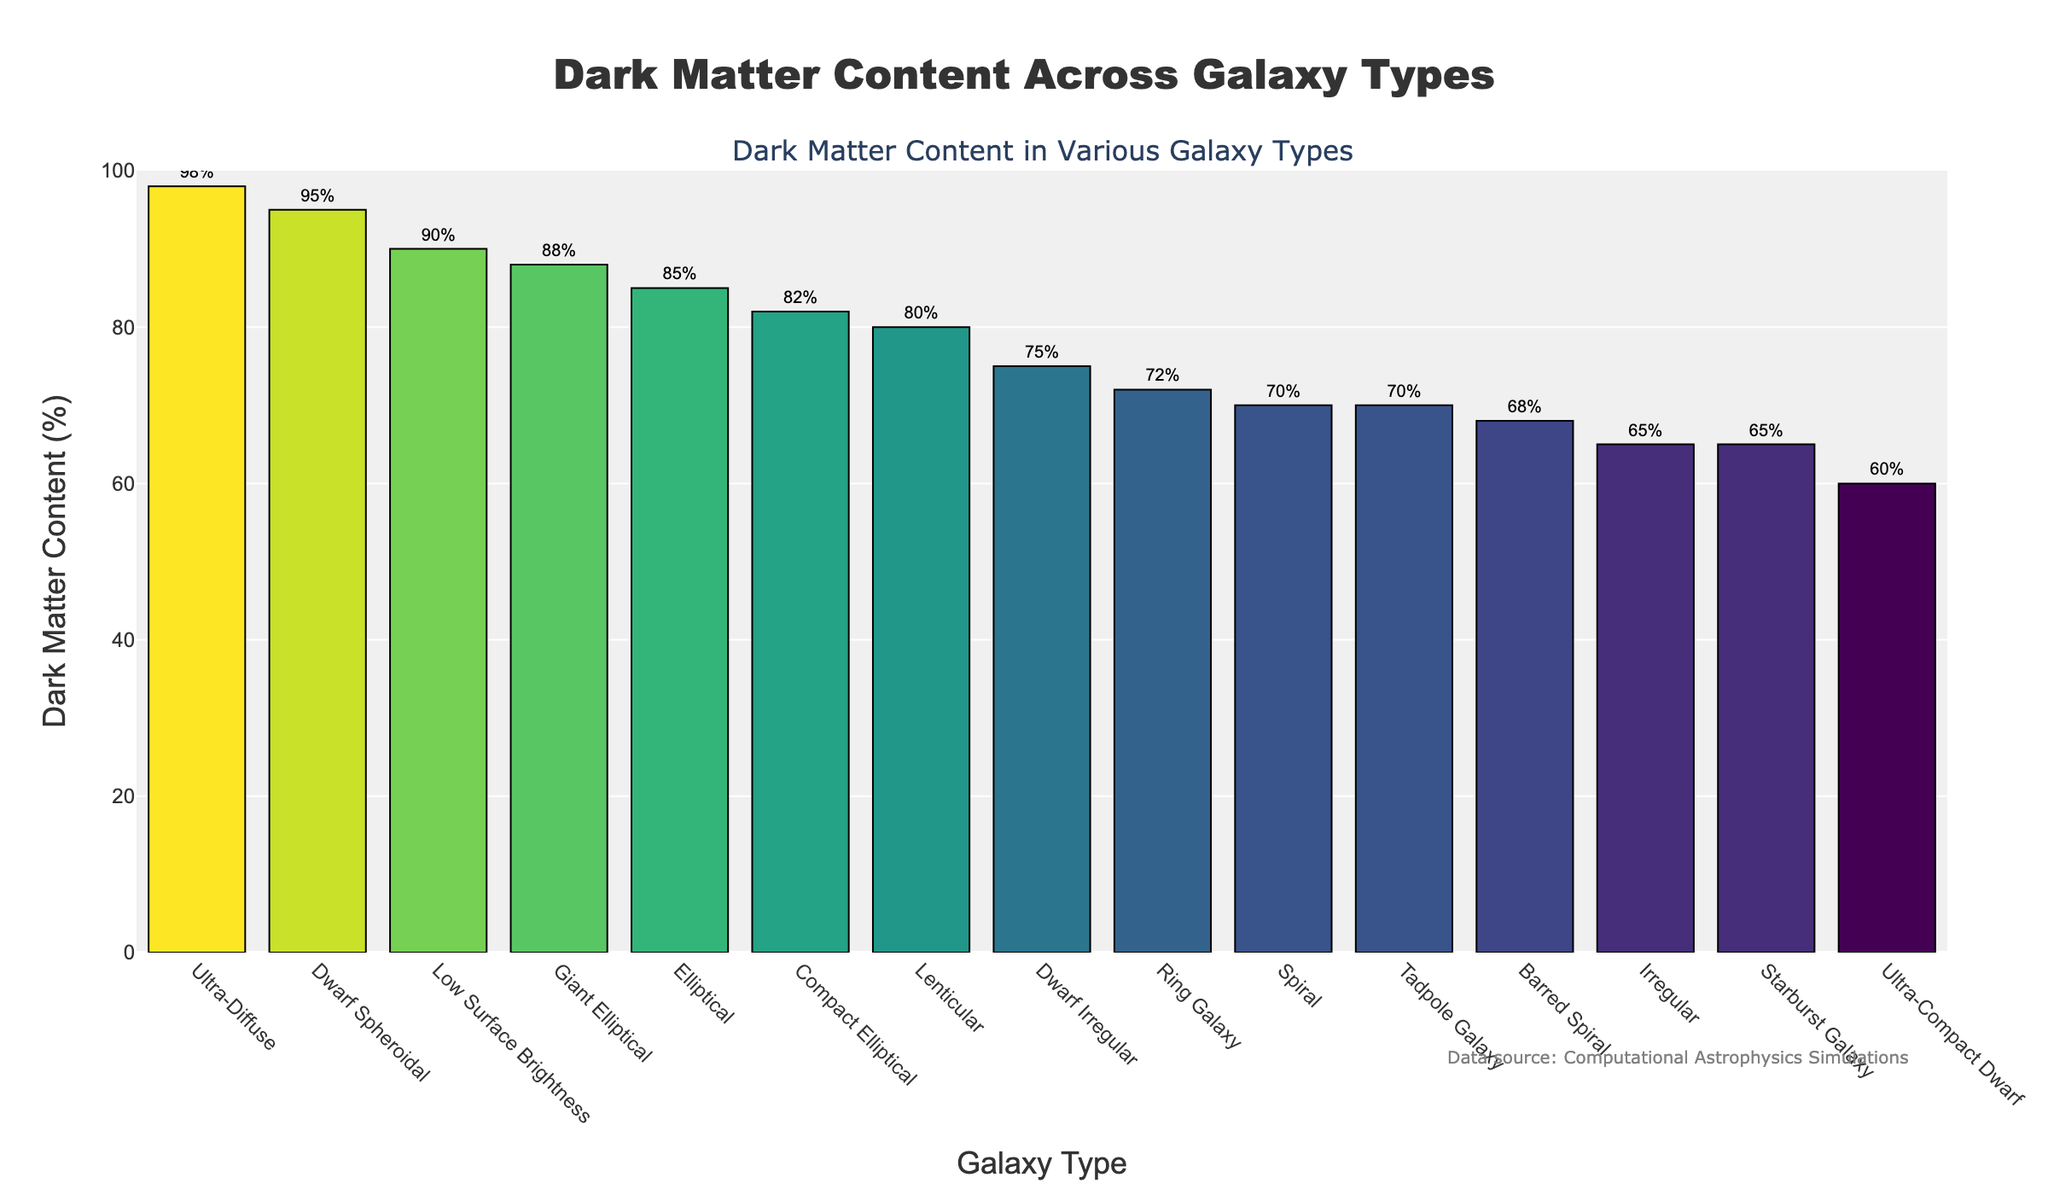What's the galaxy type with the highest dark matter content? Identify the tallest bar in the plot, which represents the galaxy type with the highest dark matter content. This bar corresponds to the Ultra-Diffuse galaxy type with a dark matter content of 98%.
Answer: Ultra-Diffuse Which galaxy type has a dark matter content of 60%? Find the bar in the plot that has a height corresponding to 60%. This bar matches the Ultra-Compact Dwarf galaxy type.
Answer: Ultra-Compact Dwarf What is the difference in dark matter content between the Dwarf Spheroidal and Starburst galaxy types? Locate the bars for Dwarf Spheroidal (95%) and Starburst (65%) galaxy types. Subtract the dark matter content of Starburst galaxy from that of Dwarf Spheroidal: 95% - 65% = 30%.
Answer: 30% Which has more dark matter content, a Spiral galaxy or a Barred Spiral galaxy? Compare the heights of the bars representing Spiral (70%) and Barred Spiral (68%) galaxy types. The Spiral galaxy has more dark matter content.
Answer: Spiral What is the average dark matter content of Elliptical, Lenticular, and Compact Elliptical galaxies? Find the dark matter content for Elliptical (85%), Lenticular (80%), and Compact Elliptical (82%) galaxies. Calculate their average: (85% + 80% + 82%) / 3 = 82.33%.
Answer: 82.33% How many galaxy types have a dark matter content of at least 70%? Count the number of bars in the plot with a height corresponding to a dark matter content of 70% or more. The galaxy types are Spiral, Ring Galaxy, Tadpole Galaxy, Dwarf Irregular, Lenticular, Compact Elliptical, Giant Elliptical, Elliptical, Low Surface Brightness, Dwarf Spheroidal, and Ultra-Diffuse, giving a total of 11 galaxy types.
Answer: 11 Which galaxy type has the median dark matter content? List the dark matter content values in ascending order: 60%, 65%, 65%, 68%, 70%, 70%, 72%, 75%, 80%, 82%, 85%, 88%, 90%, 95%, 98%. The median value is the 8th one in this list, which is 75%, corresponding to the Dwarf Irregular galaxy type.
Answer: Dwarf Irregular What is the sum of dark matter contents for the top three galaxy types? Identify the top three galaxy types by dark matter content: Ultra-Diffuse (98%), Dwarf Spheroidal (95%), and Low Surface Brightness (90%). Calculate their sum: 98% + 95% + 90% = 283%.
Answer: 283% 